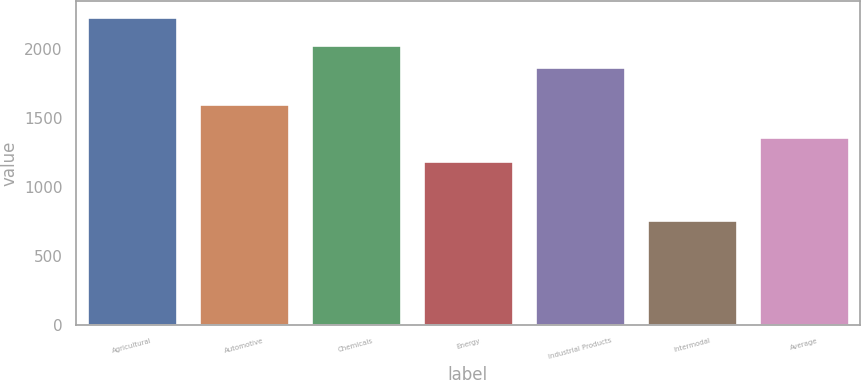Convert chart. <chart><loc_0><loc_0><loc_500><loc_500><bar_chart><fcel>Agricultural<fcel>Automotive<fcel>Chemicals<fcel>Energy<fcel>Industrial Products<fcel>Intermodal<fcel>Average<nl><fcel>2233<fcel>1598<fcel>2026<fcel>1184<fcel>1871<fcel>756<fcel>1358<nl></chart> 